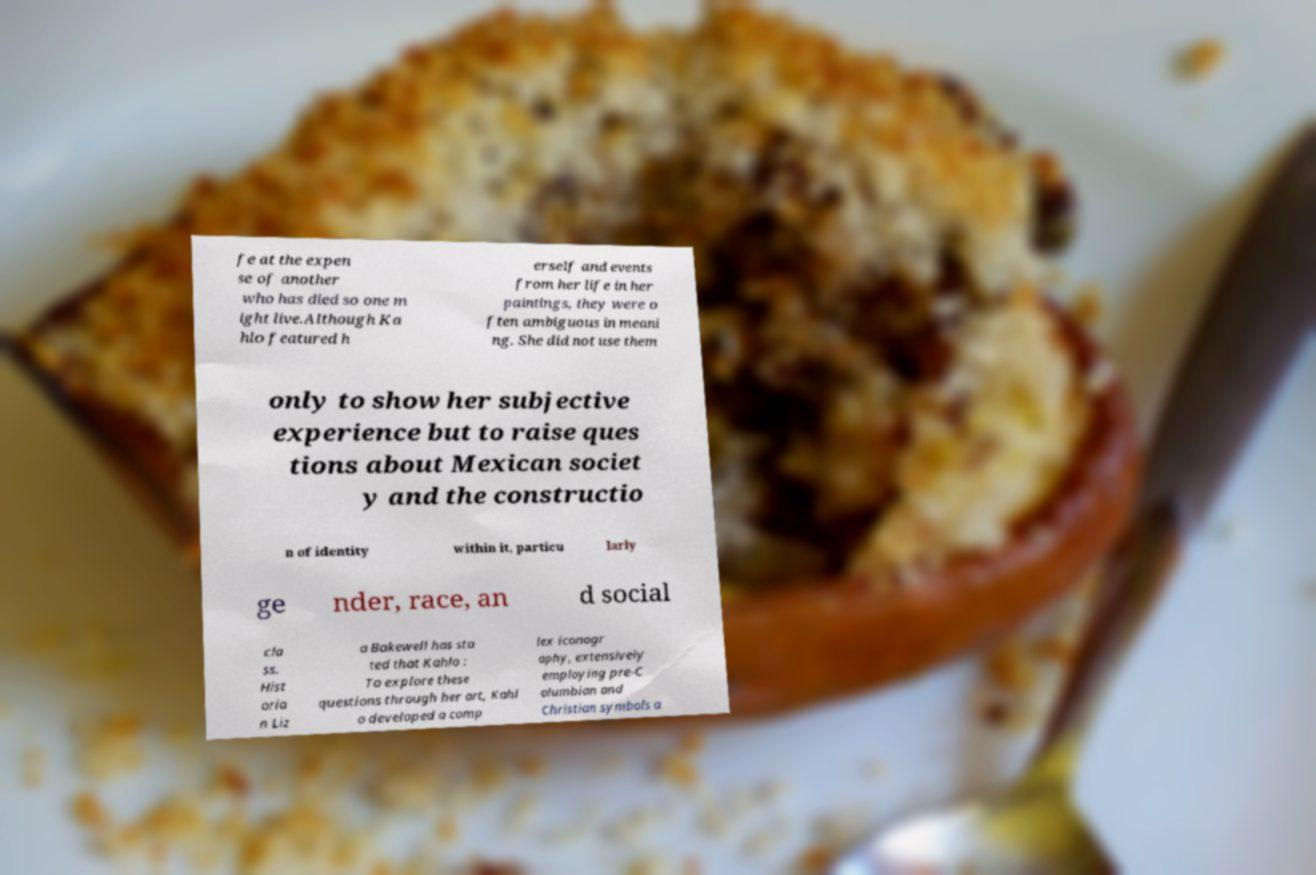What messages or text are displayed in this image? I need them in a readable, typed format. fe at the expen se of another who has died so one m ight live.Although Ka hlo featured h erself and events from her life in her paintings, they were o ften ambiguous in meani ng. She did not use them only to show her subjective experience but to raise ques tions about Mexican societ y and the constructio n of identity within it, particu larly ge nder, race, an d social cla ss. Hist oria n Liz a Bakewell has sta ted that Kahlo : To explore these questions through her art, Kahl o developed a comp lex iconogr aphy, extensively employing pre-C olumbian and Christian symbols a 